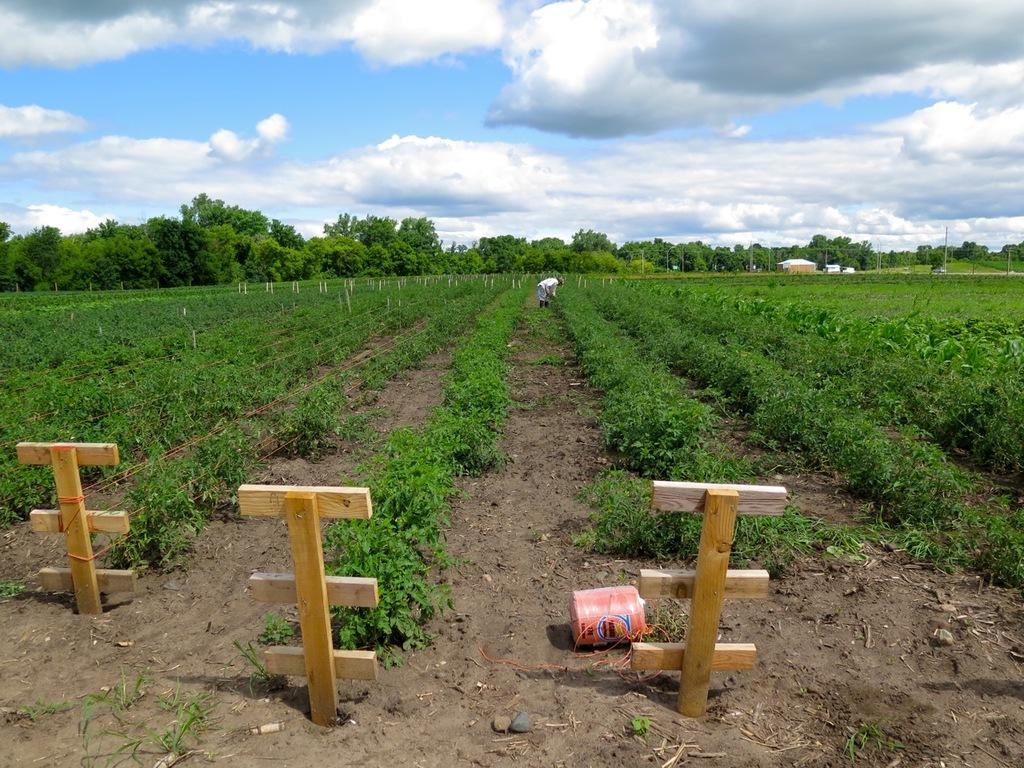What type of vegetation can be seen in the image? There are plants in a field in the image. What material are some of the objects made of in the image? There are wooden objects in the image. What type of structures can be seen in the image? There are buildings in the image. What other natural elements are present in the image? There are trees in the image. Who or what else is present in the image? There is a person in the image. What can be seen in the background of the image? The sky is visible in the background of the image. Where is the jar located in the image? There is no jar present in the image. What type of clothing is the beggar wearing in the image? There is no beggar present in the image. 